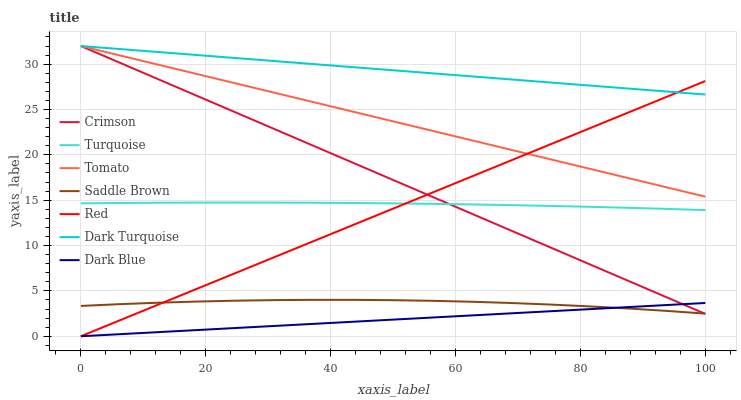Does Dark Blue have the minimum area under the curve?
Answer yes or no. Yes. Does Dark Turquoise have the maximum area under the curve?
Answer yes or no. Yes. Does Turquoise have the minimum area under the curve?
Answer yes or no. No. Does Turquoise have the maximum area under the curve?
Answer yes or no. No. Is Dark Blue the smoothest?
Answer yes or no. Yes. Is Saddle Brown the roughest?
Answer yes or no. Yes. Is Turquoise the smoothest?
Answer yes or no. No. Is Turquoise the roughest?
Answer yes or no. No. Does Turquoise have the lowest value?
Answer yes or no. No. Does Crimson have the highest value?
Answer yes or no. Yes. Does Turquoise have the highest value?
Answer yes or no. No. Is Saddle Brown less than Dark Turquoise?
Answer yes or no. Yes. Is Tomato greater than Saddle Brown?
Answer yes or no. Yes. Does Crimson intersect Red?
Answer yes or no. Yes. Is Crimson less than Red?
Answer yes or no. No. Is Crimson greater than Red?
Answer yes or no. No. Does Saddle Brown intersect Dark Turquoise?
Answer yes or no. No. 